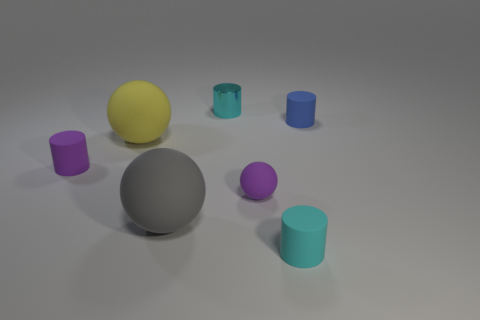Are there any metal cylinders of the same size as the yellow object?
Offer a terse response. No. There is a large rubber thing to the right of the yellow thing; is its shape the same as the yellow object?
Keep it short and to the point. Yes. The small matte sphere is what color?
Your answer should be very brief. Purple. The matte object that is the same color as the tiny metal object is what shape?
Provide a short and direct response. Cylinder. Are any rubber things visible?
Provide a succinct answer. Yes. What size is the blue cylinder that is made of the same material as the tiny purple cylinder?
Provide a succinct answer. Small. What is the shape of the small cyan thing that is in front of the small object that is to the right of the cylinder in front of the gray matte thing?
Offer a terse response. Cylinder. Are there an equal number of big matte spheres that are right of the yellow matte ball and rubber blocks?
Offer a terse response. No. What size is the cylinder that is the same color as the tiny rubber ball?
Ensure brevity in your answer.  Small. Is the shape of the blue object the same as the gray matte object?
Make the answer very short. No. 